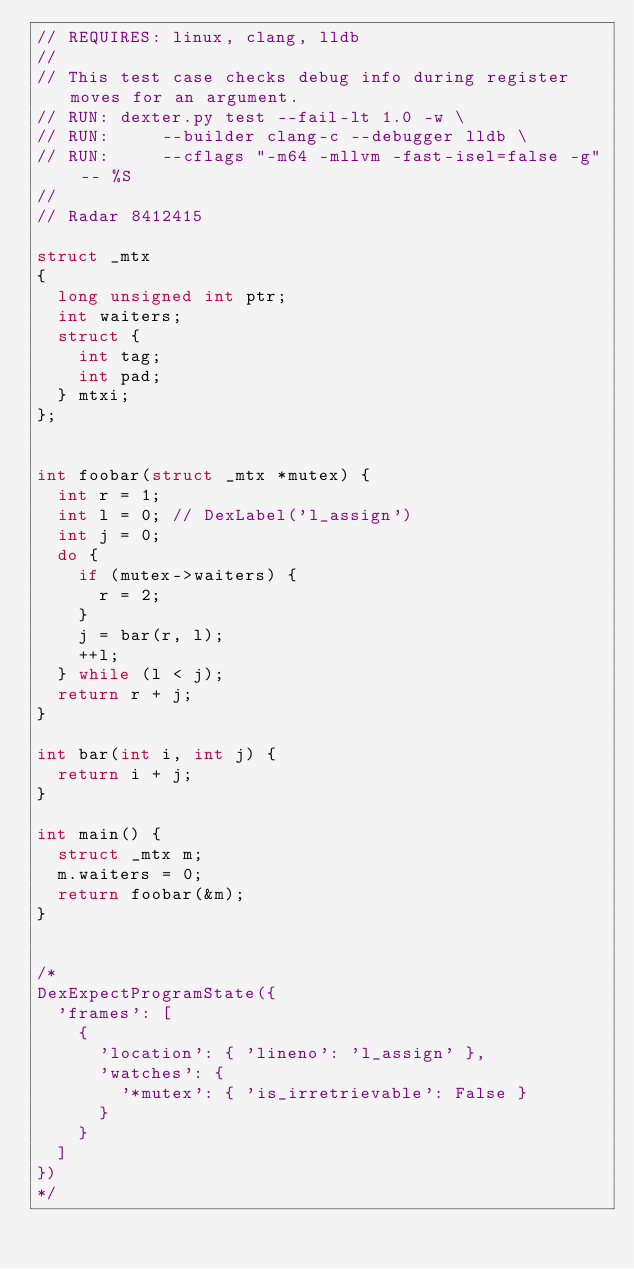Convert code to text. <code><loc_0><loc_0><loc_500><loc_500><_C_>// REQUIRES: linux, clang, lldb
//
// This test case checks debug info during register moves for an argument.
// RUN: dexter.py test --fail-lt 1.0 -w \
// RUN:     --builder clang-c --debugger lldb \
// RUN:     --cflags "-m64 -mllvm -fast-isel=false -g" -- %S
//
// Radar 8412415

struct _mtx
{
  long unsigned int ptr;
  int waiters;
  struct {
    int tag;
    int pad;
  } mtxi;
};


int foobar(struct _mtx *mutex) {
  int r = 1;
  int l = 0; // DexLabel('l_assign')
  int j = 0;
  do {
    if (mutex->waiters) {
      r = 2;
    }
    j = bar(r, l);
    ++l;
  } while (l < j);
  return r + j;
}

int bar(int i, int j) {
  return i + j;
}

int main() {
  struct _mtx m;
  m.waiters = 0;
  return foobar(&m);
}


/*
DexExpectProgramState({
  'frames': [
    {
      'location': { 'lineno': 'l_assign' },
      'watches': {
        '*mutex': { 'is_irretrievable': False }
      }
    }
  ]
})
*/

</code> 